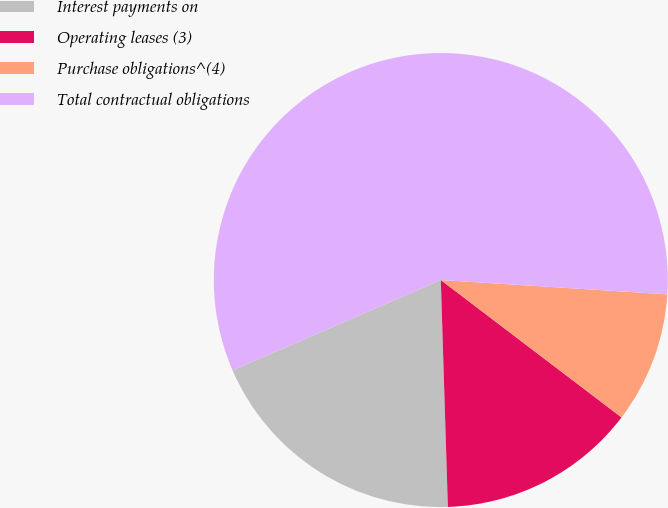Convert chart to OTSL. <chart><loc_0><loc_0><loc_500><loc_500><pie_chart><fcel>Interest payments on<fcel>Operating leases (3)<fcel>Purchase obligations^(4)<fcel>Total contractual obligations<nl><fcel>18.98%<fcel>14.16%<fcel>9.34%<fcel>57.53%<nl></chart> 